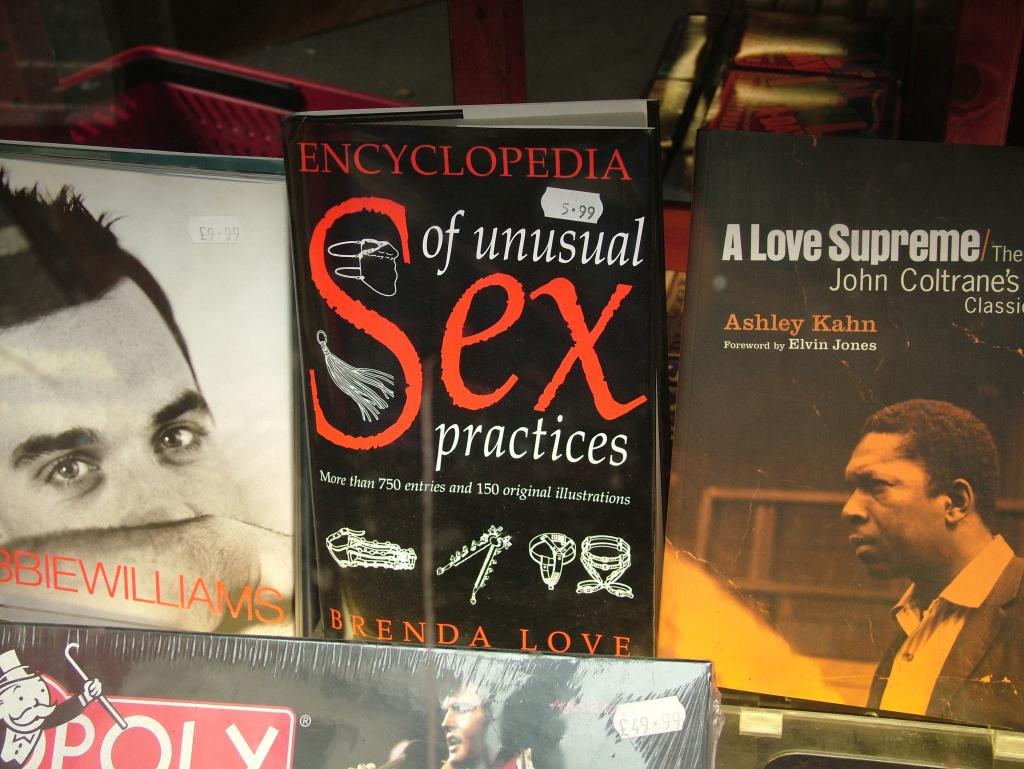What objects can be seen in the image? There are books in the image. What can be found on the books? There is text visible in the image, and pictures are present on the cover pages of the books. What type of beetle can be seen crawling on the cover of the book in the image? There is no beetle present in the image; the image only features books with text and pictures on their cover pages. 